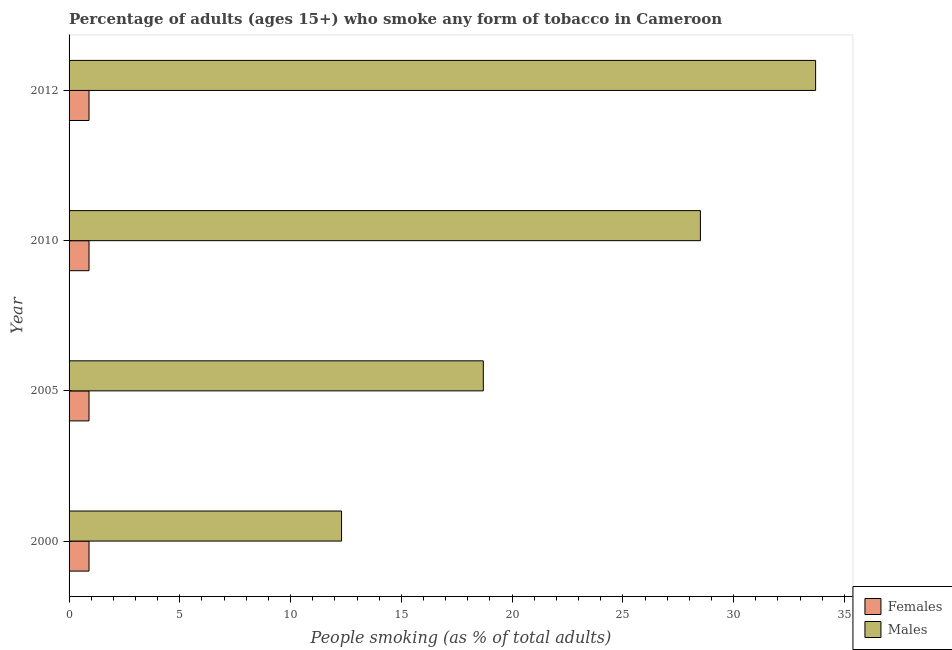How many different coloured bars are there?
Offer a terse response. 2. Across all years, what is the maximum percentage of males who smoke?
Offer a terse response. 33.7. What is the total percentage of females who smoke in the graph?
Offer a very short reply. 3.6. What is the difference between the percentage of males who smoke in 2000 and that in 2010?
Provide a succinct answer. -16.2. What is the average percentage of males who smoke per year?
Offer a very short reply. 23.3. In the year 2010, what is the difference between the percentage of males who smoke and percentage of females who smoke?
Ensure brevity in your answer.  27.6. In how many years, is the percentage of females who smoke greater than 16 %?
Your response must be concise. 0. What is the ratio of the percentage of males who smoke in 2000 to that in 2005?
Give a very brief answer. 0.66. What is the difference between the highest and the second highest percentage of males who smoke?
Your response must be concise. 5.2. What is the difference between the highest and the lowest percentage of females who smoke?
Keep it short and to the point. 0. What does the 2nd bar from the top in 2000 represents?
Your answer should be very brief. Females. What does the 2nd bar from the bottom in 2000 represents?
Provide a short and direct response. Males. How many bars are there?
Ensure brevity in your answer.  8. Are all the bars in the graph horizontal?
Make the answer very short. Yes. Are the values on the major ticks of X-axis written in scientific E-notation?
Provide a succinct answer. No. What is the title of the graph?
Offer a terse response. Percentage of adults (ages 15+) who smoke any form of tobacco in Cameroon. What is the label or title of the X-axis?
Ensure brevity in your answer.  People smoking (as % of total adults). What is the People smoking (as % of total adults) of Females in 2000?
Your answer should be very brief. 0.9. What is the People smoking (as % of total adults) of Females in 2005?
Your answer should be very brief. 0.9. What is the People smoking (as % of total adults) of Males in 2012?
Offer a terse response. 33.7. Across all years, what is the maximum People smoking (as % of total adults) in Females?
Offer a very short reply. 0.9. Across all years, what is the maximum People smoking (as % of total adults) of Males?
Provide a succinct answer. 33.7. Across all years, what is the minimum People smoking (as % of total adults) in Males?
Provide a short and direct response. 12.3. What is the total People smoking (as % of total adults) of Males in the graph?
Offer a very short reply. 93.2. What is the difference between the People smoking (as % of total adults) in Females in 2000 and that in 2005?
Your answer should be compact. 0. What is the difference between the People smoking (as % of total adults) in Males in 2000 and that in 2010?
Your answer should be compact. -16.2. What is the difference between the People smoking (as % of total adults) of Males in 2000 and that in 2012?
Give a very brief answer. -21.4. What is the difference between the People smoking (as % of total adults) in Females in 2005 and that in 2010?
Ensure brevity in your answer.  0. What is the difference between the People smoking (as % of total adults) of Males in 2005 and that in 2012?
Give a very brief answer. -15. What is the difference between the People smoking (as % of total adults) in Females in 2000 and the People smoking (as % of total adults) in Males in 2005?
Keep it short and to the point. -17.8. What is the difference between the People smoking (as % of total adults) in Females in 2000 and the People smoking (as % of total adults) in Males in 2010?
Give a very brief answer. -27.6. What is the difference between the People smoking (as % of total adults) in Females in 2000 and the People smoking (as % of total adults) in Males in 2012?
Offer a very short reply. -32.8. What is the difference between the People smoking (as % of total adults) of Females in 2005 and the People smoking (as % of total adults) of Males in 2010?
Your answer should be compact. -27.6. What is the difference between the People smoking (as % of total adults) in Females in 2005 and the People smoking (as % of total adults) in Males in 2012?
Provide a short and direct response. -32.8. What is the difference between the People smoking (as % of total adults) of Females in 2010 and the People smoking (as % of total adults) of Males in 2012?
Provide a short and direct response. -32.8. What is the average People smoking (as % of total adults) in Males per year?
Offer a very short reply. 23.3. In the year 2005, what is the difference between the People smoking (as % of total adults) of Females and People smoking (as % of total adults) of Males?
Provide a succinct answer. -17.8. In the year 2010, what is the difference between the People smoking (as % of total adults) of Females and People smoking (as % of total adults) of Males?
Give a very brief answer. -27.6. In the year 2012, what is the difference between the People smoking (as % of total adults) of Females and People smoking (as % of total adults) of Males?
Provide a succinct answer. -32.8. What is the ratio of the People smoking (as % of total adults) of Males in 2000 to that in 2005?
Offer a terse response. 0.66. What is the ratio of the People smoking (as % of total adults) of Females in 2000 to that in 2010?
Make the answer very short. 1. What is the ratio of the People smoking (as % of total adults) of Males in 2000 to that in 2010?
Your response must be concise. 0.43. What is the ratio of the People smoking (as % of total adults) in Females in 2000 to that in 2012?
Offer a very short reply. 1. What is the ratio of the People smoking (as % of total adults) in Males in 2000 to that in 2012?
Provide a succinct answer. 0.36. What is the ratio of the People smoking (as % of total adults) in Males in 2005 to that in 2010?
Ensure brevity in your answer.  0.66. What is the ratio of the People smoking (as % of total adults) in Males in 2005 to that in 2012?
Give a very brief answer. 0.55. What is the ratio of the People smoking (as % of total adults) of Females in 2010 to that in 2012?
Your response must be concise. 1. What is the ratio of the People smoking (as % of total adults) of Males in 2010 to that in 2012?
Offer a very short reply. 0.85. What is the difference between the highest and the second highest People smoking (as % of total adults) of Females?
Your response must be concise. 0. What is the difference between the highest and the lowest People smoking (as % of total adults) in Males?
Your response must be concise. 21.4. 